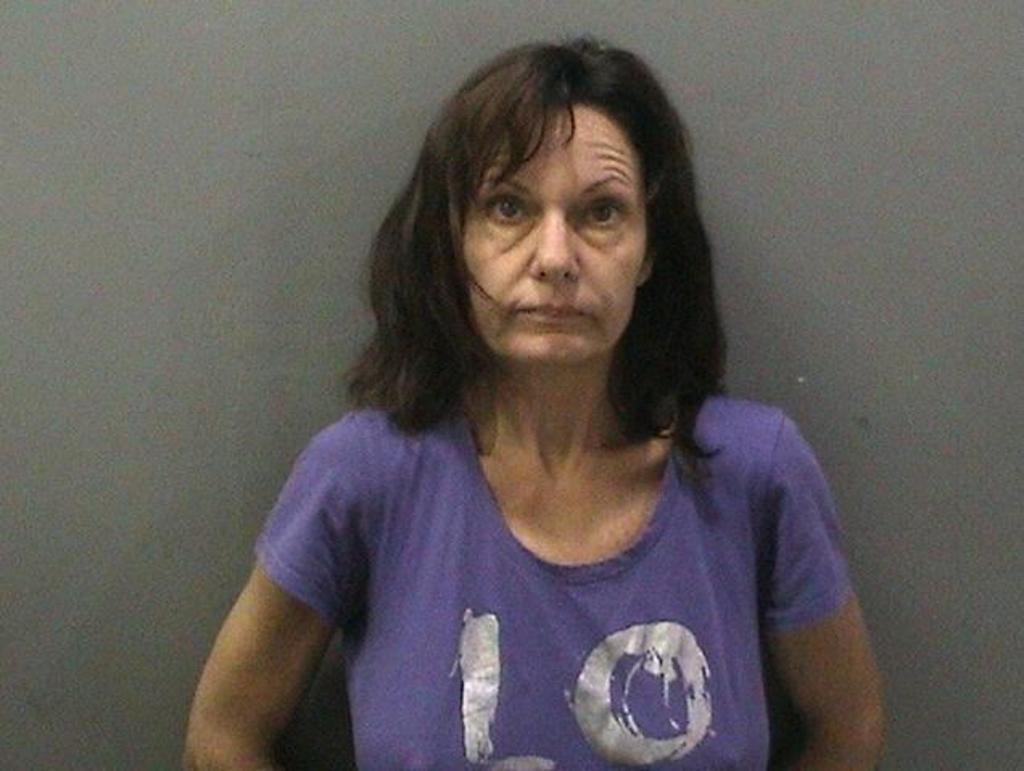Who is present in the image? There is a woman in the image. What is the woman wearing? The woman is wearing a t-shirt. What is the woman doing in the image? The woman is looking at a picture. What can be seen in the background of the image? There is a wall in the background of the image. What type of snake can be seen slithering on the floor in the image? There is no snake present in the image; it only features a woman looking at a picture with a wall in the background. 